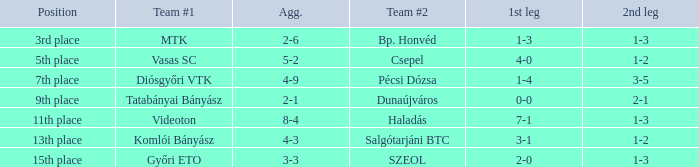Which role has a 2-6 aggregate? 3rd place. 